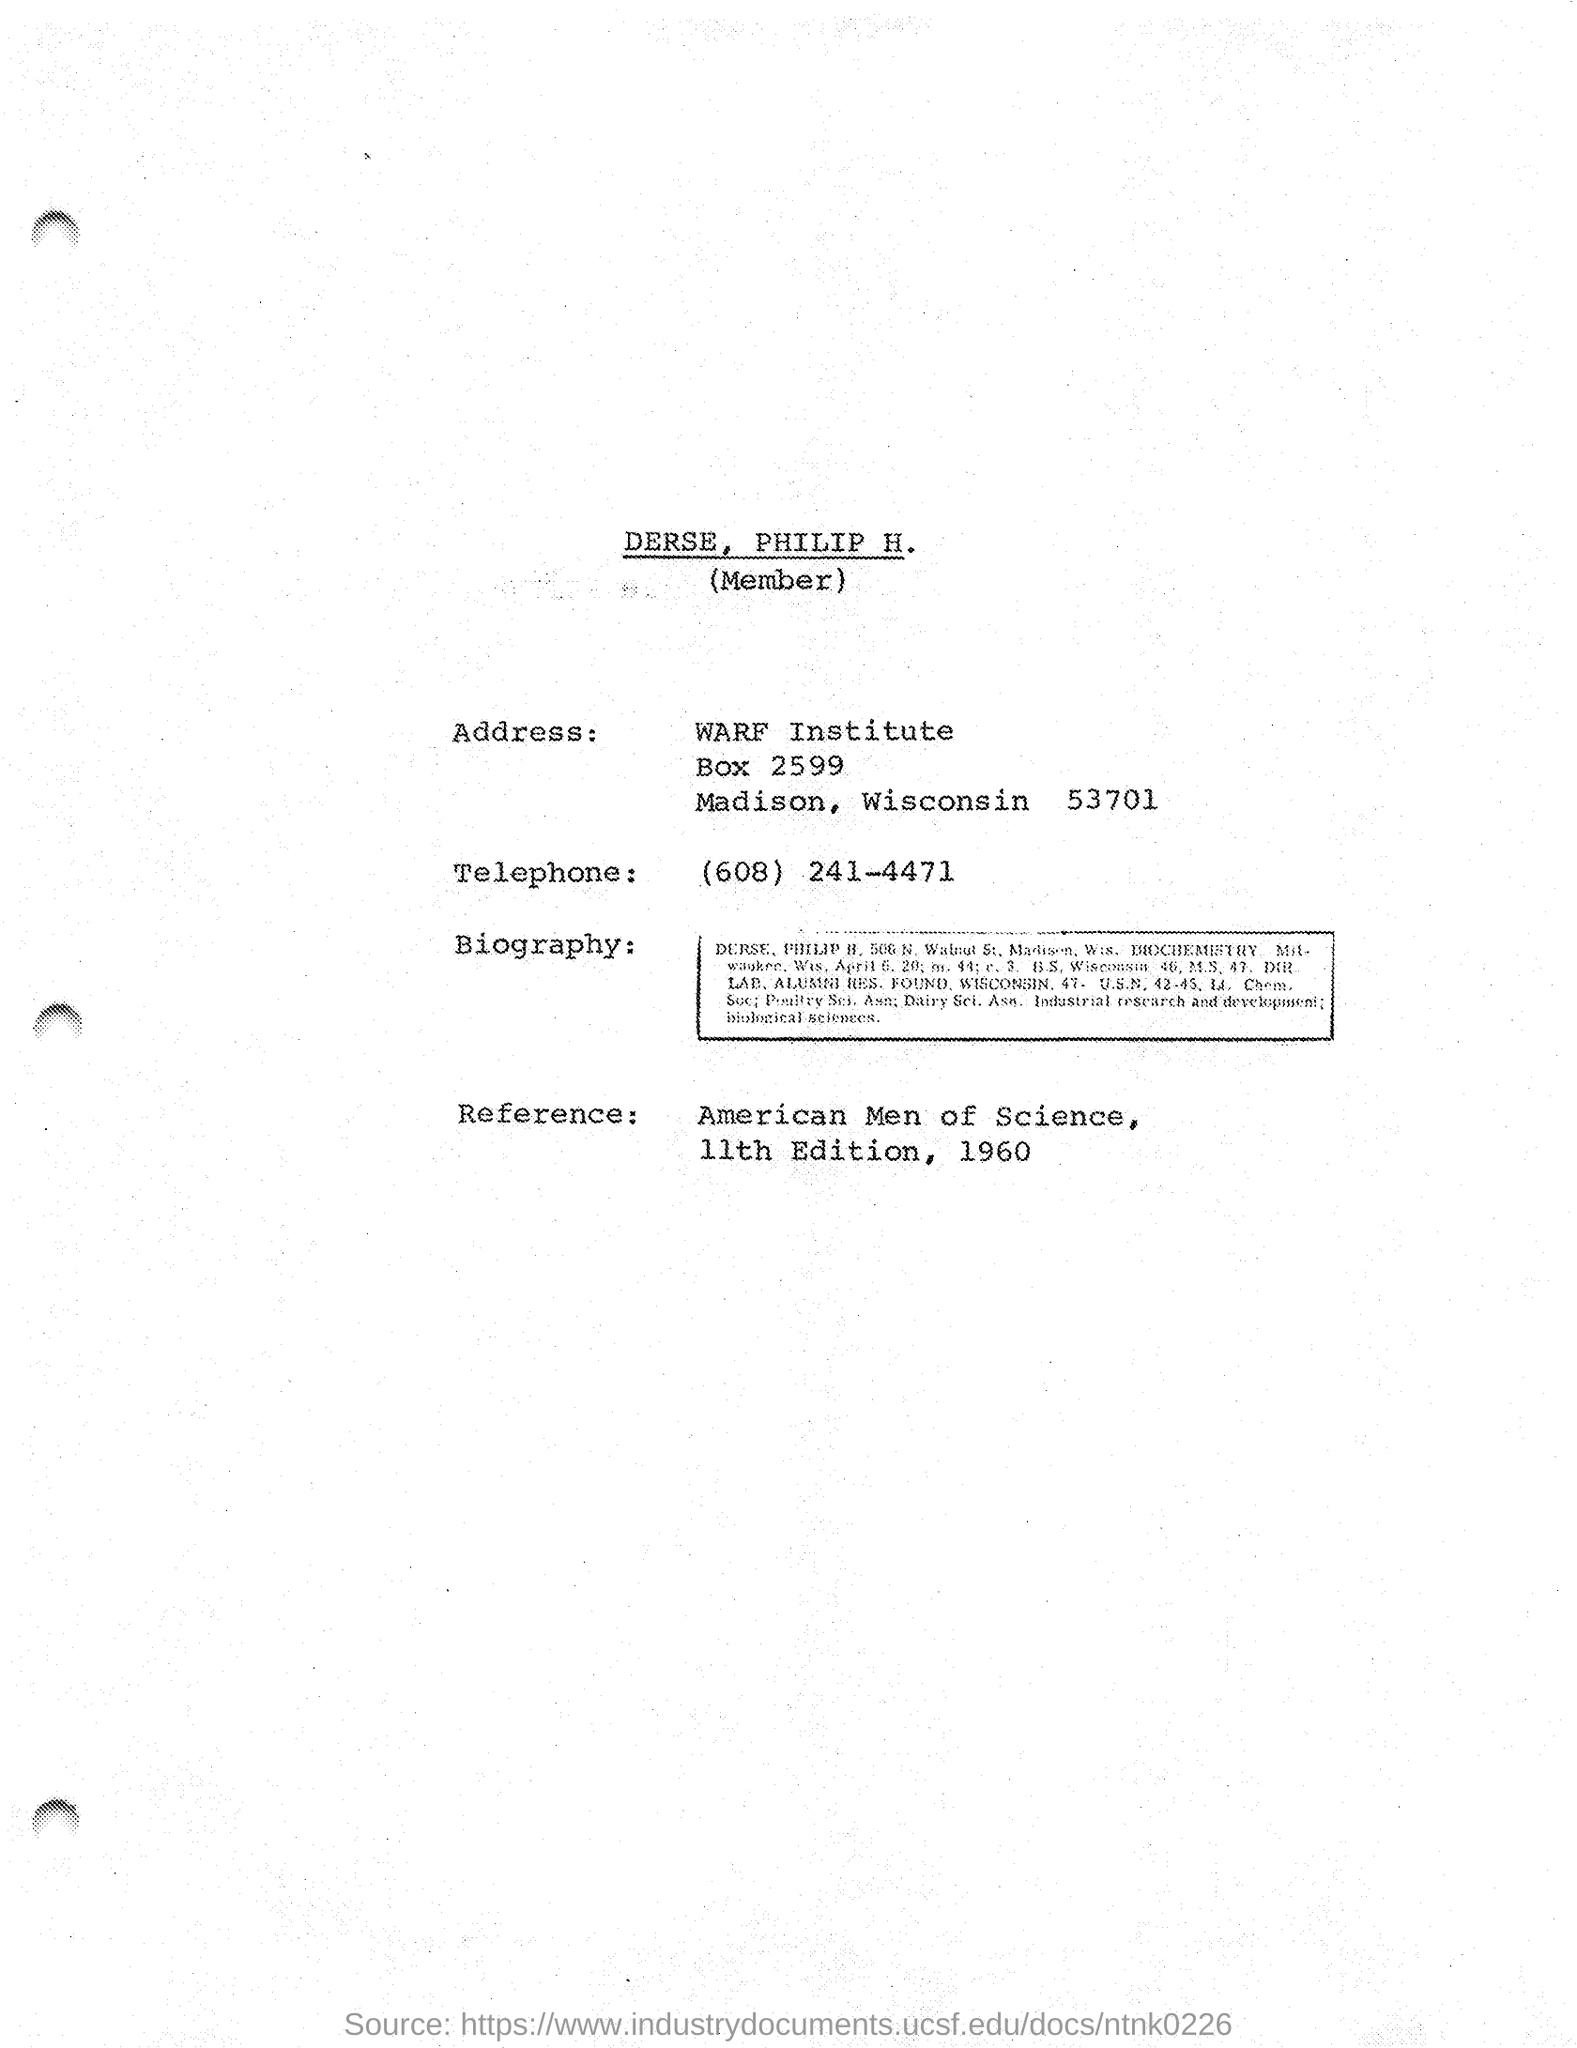Who is the member mentioned in this document?
Give a very brief answer. DERSE, PHILIP H. Which city DERSE, PHILIP H. belongs to?
Offer a terse response. Madison. What is the Telephone No mentioned in this document?
Keep it short and to the point. (608) 241-4471. What is the Reference given in this document?
Your answer should be very brief. American Men of Science, 11th Edition, 1960. 